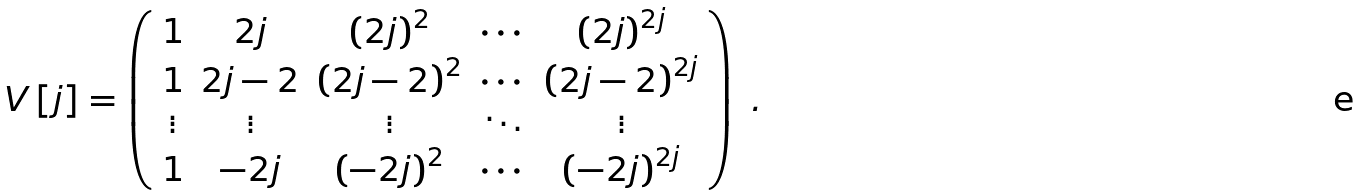Convert formula to latex. <formula><loc_0><loc_0><loc_500><loc_500>V \left [ j \right ] = \left ( \begin{array} [ c ] { c c c c c } 1 & 2 j & \left ( 2 j \right ) ^ { 2 } & \cdots & \left ( 2 j \right ) ^ { 2 j } \\ 1 & 2 j - 2 & \left ( 2 j - 2 \right ) ^ { 2 } & \cdots & \left ( 2 j - 2 \right ) ^ { 2 j } \\ \vdots & \vdots & \vdots & \ddots & \vdots \\ 1 & - 2 j & \left ( - 2 j \right ) ^ { 2 } & \cdots & \left ( - 2 j \right ) ^ { 2 j } \end{array} \right ) \ .</formula> 